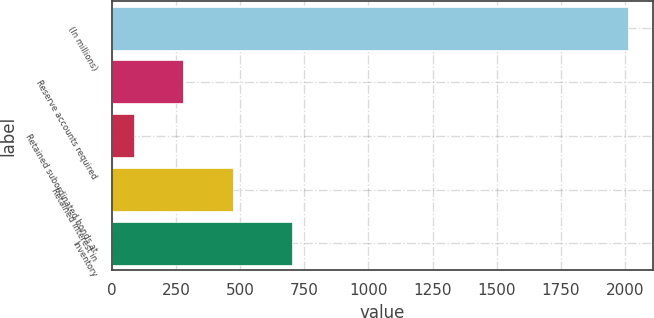<chart> <loc_0><loc_0><loc_500><loc_500><bar_chart><fcel>(In millions)<fcel>Reserve accounts required<fcel>Retained subordinated bonds at<fcel>Retained interest in<fcel>Inventory<nl><fcel>2009<fcel>279.56<fcel>87.4<fcel>471.72<fcel>703.2<nl></chart> 